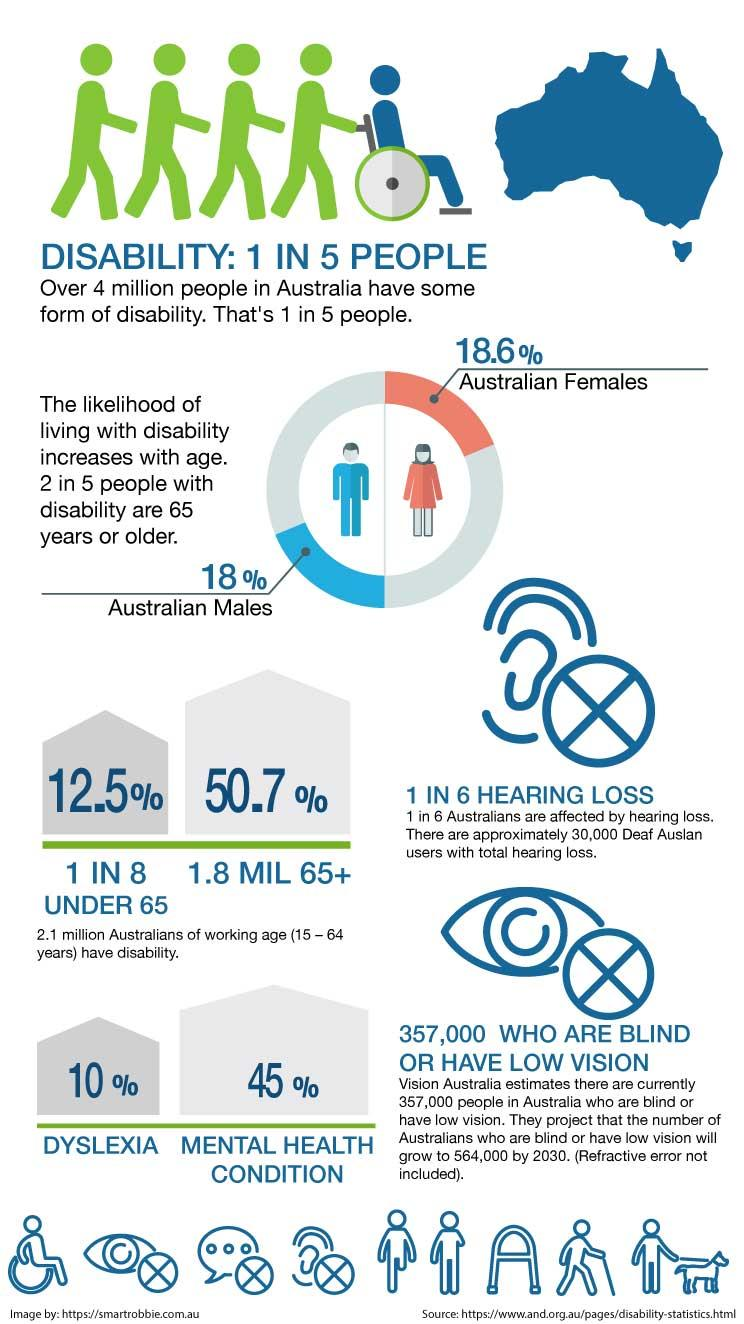Give some essential details in this illustration. According to a recent survey, approximately 45% of Australians are affected by a mental health condition. According to statistics, for Australians, the prevalence of dyslexia or mental health conditions is higher compared to other developed countries. Specifically, mental health conditions are more prevalent in the Australian population. In terms of disability prevalence, females are more likely to fall into this category compared to males. Out of the five people considered, four of them are not disabled in Australia. According to recent data, approximately 10% of Australians are affected by dyslexia. 